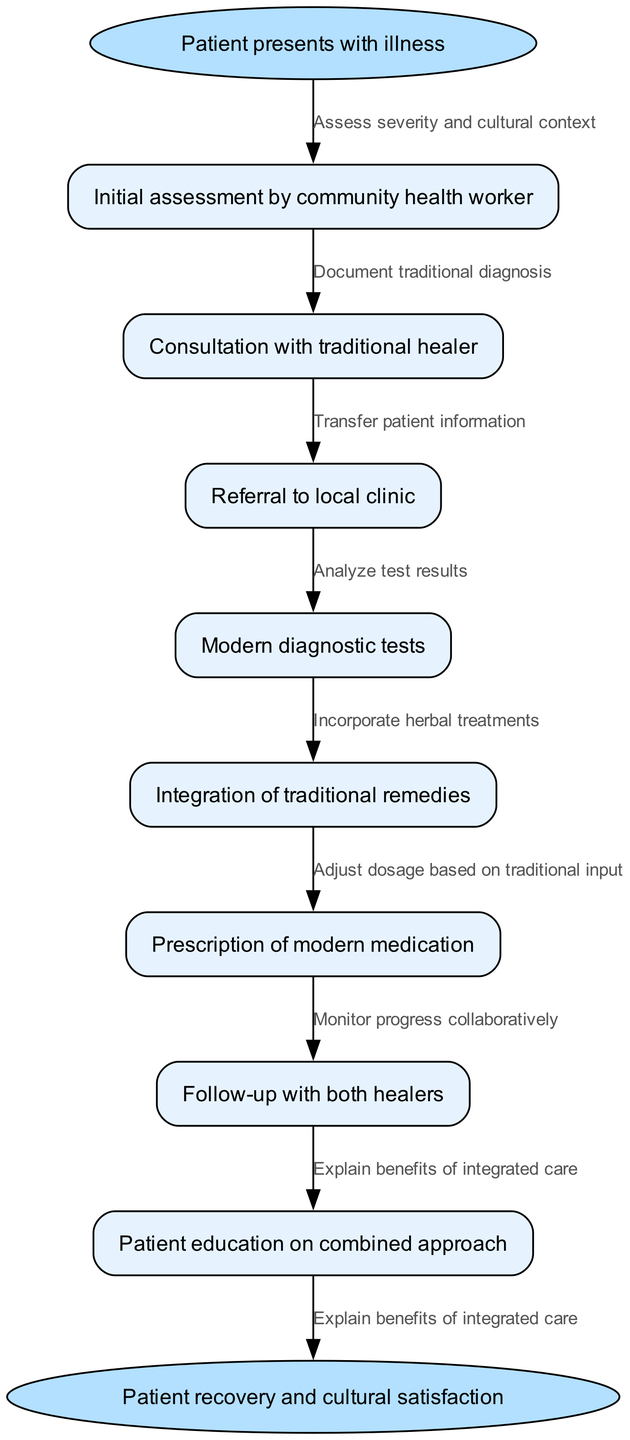What is the starting point of the clinical pathway? The diagram indicates that the starting point is "Patient presents with illness." This is the initial event that triggers the entire pathway process.
Answer: Patient presents with illness How many nodes are in the diagram? By counting the nodes listed in the diagram, we can identify there are a total of 8 nodes, including the start and end points.
Answer: 8 What node follows the "Consultation with traditional healer"? The diagram clearly outlines the order of nodes; after "Consultation with traditional healer," the next node is "Referral to local clinic."
Answer: Referral to local clinic Which node is connected to the edge "Document traditional diagnosis"? The edge "Document traditional diagnosis" connects the node "Consultation with traditional healer" to the next step in the pathway, which is "Referral to local clinic."
Answer: Referral to local clinic Which two nodes are connected by the edge "Incorporate herbal treatments"? According to the diagram, the edge "Incorporate herbal treatments" connects "Modern diagnostic tests" and "Integration of traditional remedies."
Answer: Modern diagnostic tests and Integration of traditional remedies What is the final outcome in this clinical pathway? The end point of the diagram states that the final outcome is "Patient recovery and cultural satisfaction," which encapsulates the ultimate goal of integrating both healing practices.
Answer: Patient recovery and cultural satisfaction How does the pathway ensure monitoring of patient progress? The diagram indicates that "Monitor progress collaboratively" occurs after the "Follow-up with both healers," ensuring that the patient’s health is evaluated through both traditional and modern care perspectives.
Answer: Monitor progress collaboratively What is the significance of patient education in this pathway? The node "Patient education on combined approach" highlights the importance of ensuring that patients are aware of how traditional and modern practices can work together, contributing to their overall health and satisfaction.
Answer: Patient education on combined approach 